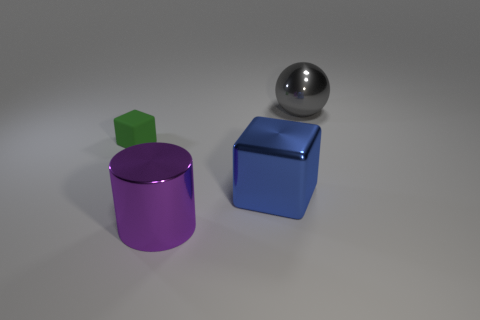Is there anything else that has the same material as the green block?
Your answer should be very brief. No. Do the object to the left of the purple cylinder and the big gray object have the same shape?
Your response must be concise. No. There is a green thing that is the same shape as the large blue metallic thing; what is its material?
Offer a terse response. Rubber. Do the gray object and the thing to the left of the purple object have the same shape?
Offer a terse response. No. There is a thing that is both to the right of the purple thing and behind the big blue thing; what is its color?
Offer a very short reply. Gray. Are any tiny yellow matte spheres visible?
Provide a succinct answer. No. Is the number of gray metallic spheres to the left of the gray sphere the same as the number of large metal spheres?
Keep it short and to the point. No. What number of other things are the same shape as the large gray object?
Give a very brief answer. 0. There is a big gray thing; what shape is it?
Ensure brevity in your answer.  Sphere. Are the green block and the big purple cylinder made of the same material?
Provide a short and direct response. No. 